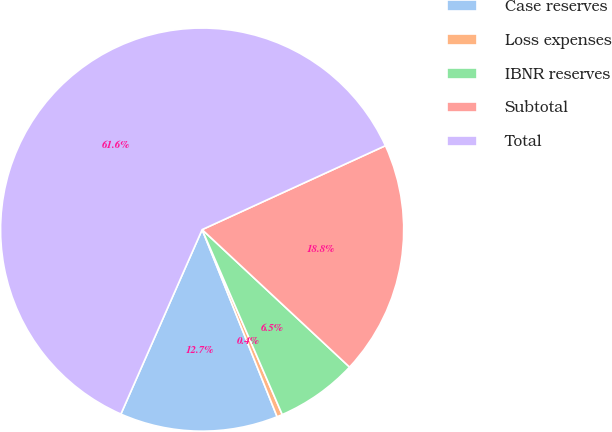<chart> <loc_0><loc_0><loc_500><loc_500><pie_chart><fcel>Case reserves<fcel>Loss expenses<fcel>IBNR reserves<fcel>Subtotal<fcel>Total<nl><fcel>12.67%<fcel>0.44%<fcel>6.55%<fcel>18.78%<fcel>61.56%<nl></chart> 